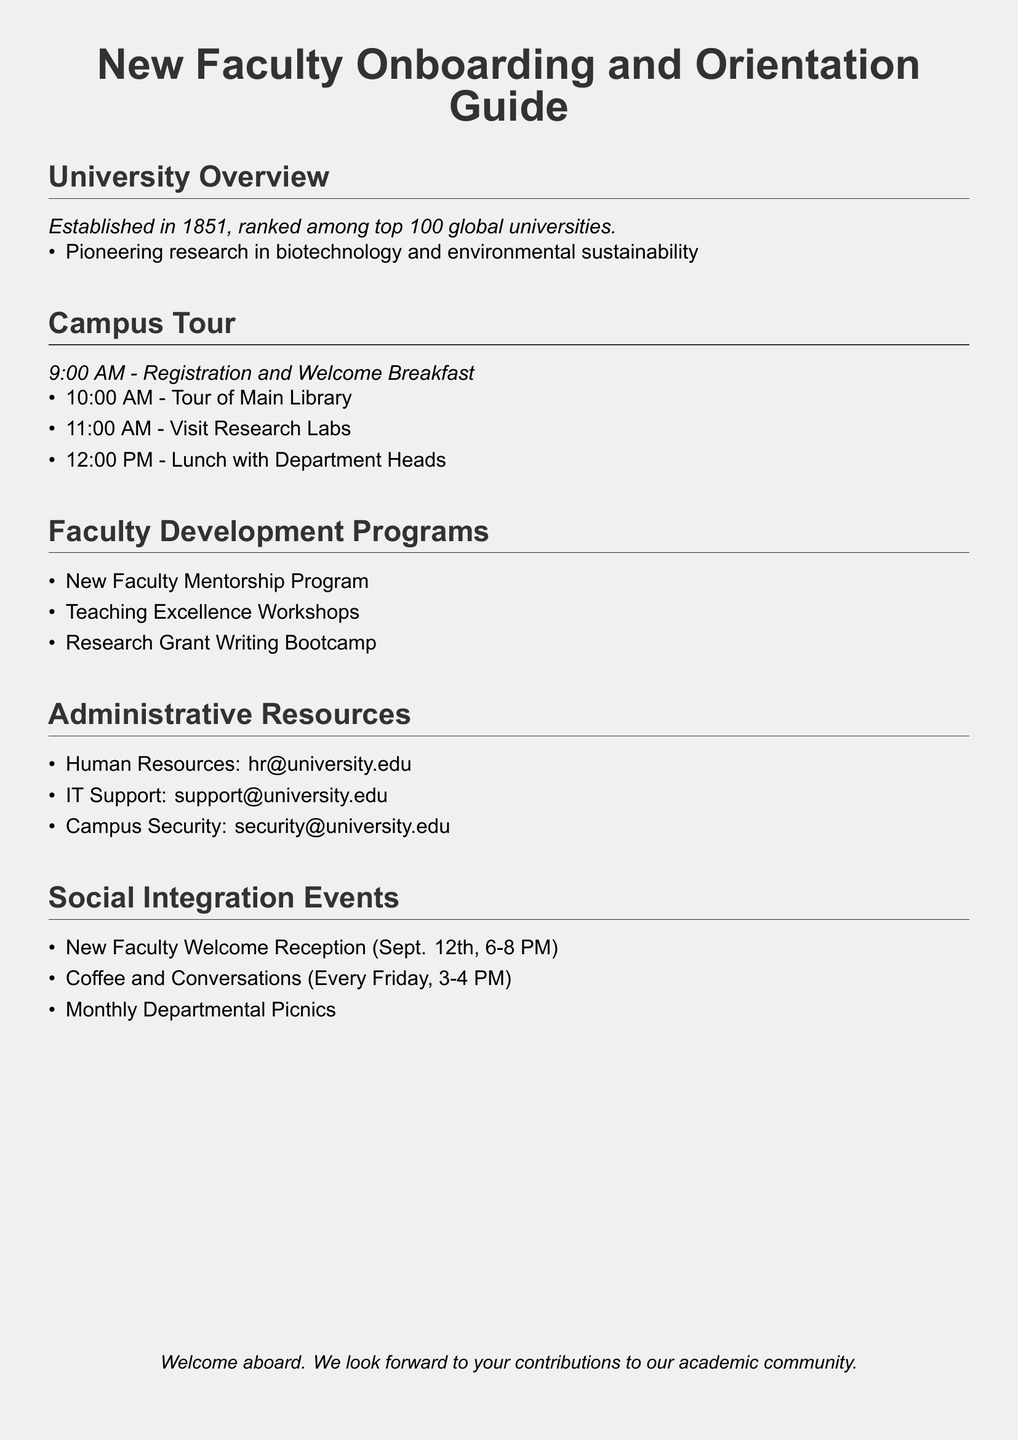What year was the university established? The university was established in 1851, as mentioned in the University Overview section.
Answer: 1851 What is one area of pioneering research at the university? The document lists biotechnology and environmental sustainability as areas of pioneering research in the University Overview.
Answer: Biotechnology When does the New Faculty Welcome Reception take place? The date for the New Faculty Welcome Reception is specified as September 12th in the Social Integration Events section.
Answer: September 12th What time does the coffee and conversations event occur? The document states that Coffee and Conversations happens every Friday from 3 to 4 PM in the Social Integration Events section.
Answer: 3-4 PM How many events are listed under Social Integration Events? The Social Integration Events section lists three different events for social integration.
Answer: Three What type of program is the New Faculty Mentorship Program? This is listed under Faculty Development Programs, indicating it supports mentorship for new faculty.
Answer: Mentorship What are the contact details for IT Support? The contact information for IT Support is provided in the Administrative Resources section as an email address.
Answer: support@university.edu What is the purpose of the Teaching Excellence Workshops? Reasoning requires combining the information from the Faculty Development Programs section, where workshops aimed at enhancing teaching quality are mentioned.
Answer: Enhance teaching quality How many hours does the campus tour start after the welcome breakfast? The campus tour starts at 10:00 AM, which is one hour after the welcome breakfast that starts at 9:00 AM.
Answer: One hour What is the color of the page background? The background color is specified in the document as light gray.
Answer: Light gray 